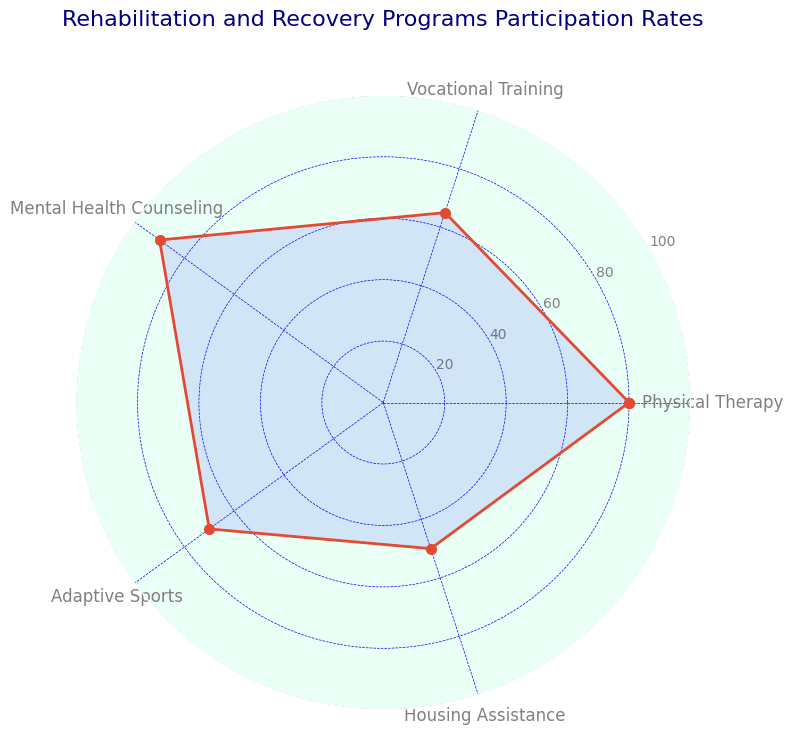Which rehabilitation and recovery program has the highest participation rate? By observing the highest peak in the radar chart, we can see that Mental Health Counseling has the highest point at 90%.
Answer: Mental Health Counseling Which rehabilitation and recovery program has the lowest participation rate? By observing the lowest point in the radar chart, we can see that Housing Assistance has the lowest point at 50%.
Answer: Housing Assistance What is the difference between the participation rates of Physical Therapy and Mental Health Counseling? The participation rate of Physical Therapy is 80%, and Mental Health Counseling is 90%. The difference is 90% - 80% = 10%.
Answer: 10% Which program has a higher participation rate: Vocational Training or Adaptive Sports? By comparing the points in the radar chart, we can see that Vocational Training has a participation rate of 65%, whereas Adaptive Sports has a rate of 70%. Therefore, Adaptive Sports has a higher participation rate.
Answer: Adaptive Sports What is the average participation rate of all the rehabilitation and recovery programs? The participation rates are 80%, 65%, 90%, 70%, and 50%. Summing these values gives 80 + 65 + 90 + 70 + 50 = 355. Dividing by the number of programs (5) gives 355 / 5 = 71%.
Answer: 71% What is the sum of participation rates for Physical Therapy and Adaptive Sports? The participation rates for Physical Therapy and Adaptive Sports are 80% and 70%, respectively. Summing these values gives 80 + 70 = 150%.
Answer: 150% Are any of the participation rates equal to or greater than 90%? By examining the radar chart, we can see that the participation rate for Mental Health Counseling is 90%, which is equal to 90%.
Answer: Yes Which program has a smaller participation rate: Housing Assistance or Vocational Training? By comparing the points in the radar chart, we can see that Housing Assistance has a participation rate of 50%, and Vocational Training has a rate of 65%. Therefore, Housing Assistance has a smaller participation rate.
Answer: Housing Assistance What is the difference between the highest and lowest participation rates? The highest participation rate is 90% for Mental Health Counseling, and the lowest participation rate is 50% for Housing Assistance. The difference is 90% - 50% = 40%.
Answer: 40% Which program is right in the middle when ordered by participation rate from lowest to highest? The participation rates in order from lowest to highest are: Housing Assistance (50%), Vocational Training (65%), Adaptive Sports (70%), Physical Therapy (80%), and Mental Health Counseling (90%). The middle value is Adaptive Sports at 70%.
Answer: Adaptive Sports 